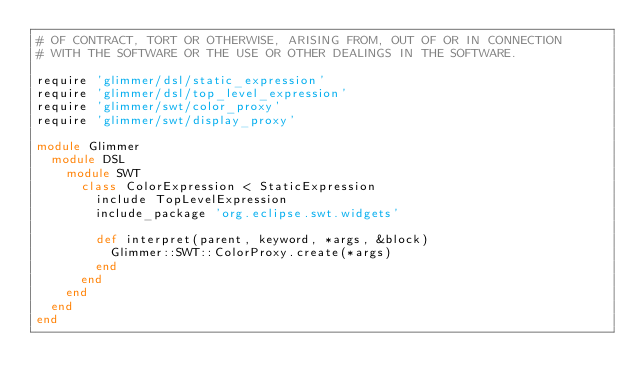<code> <loc_0><loc_0><loc_500><loc_500><_Ruby_># OF CONTRACT, TORT OR OTHERWISE, ARISING FROM, OUT OF OR IN CONNECTION
# WITH THE SOFTWARE OR THE USE OR OTHER DEALINGS IN THE SOFTWARE.

require 'glimmer/dsl/static_expression'
require 'glimmer/dsl/top_level_expression'
require 'glimmer/swt/color_proxy'
require 'glimmer/swt/display_proxy'

module Glimmer
  module DSL
    module SWT
      class ColorExpression < StaticExpression
        include TopLevelExpression
        include_package 'org.eclipse.swt.widgets'
  
        def interpret(parent, keyword, *args, &block)
          Glimmer::SWT::ColorProxy.create(*args)
        end
      end
    end
  end
end
</code> 